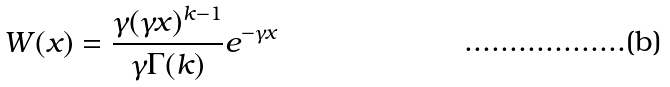Convert formula to latex. <formula><loc_0><loc_0><loc_500><loc_500>W ( x ) = \frac { \gamma ( \gamma x ) ^ { k - 1 } } { \gamma \Gamma ( k ) } e ^ { - \gamma x }</formula> 